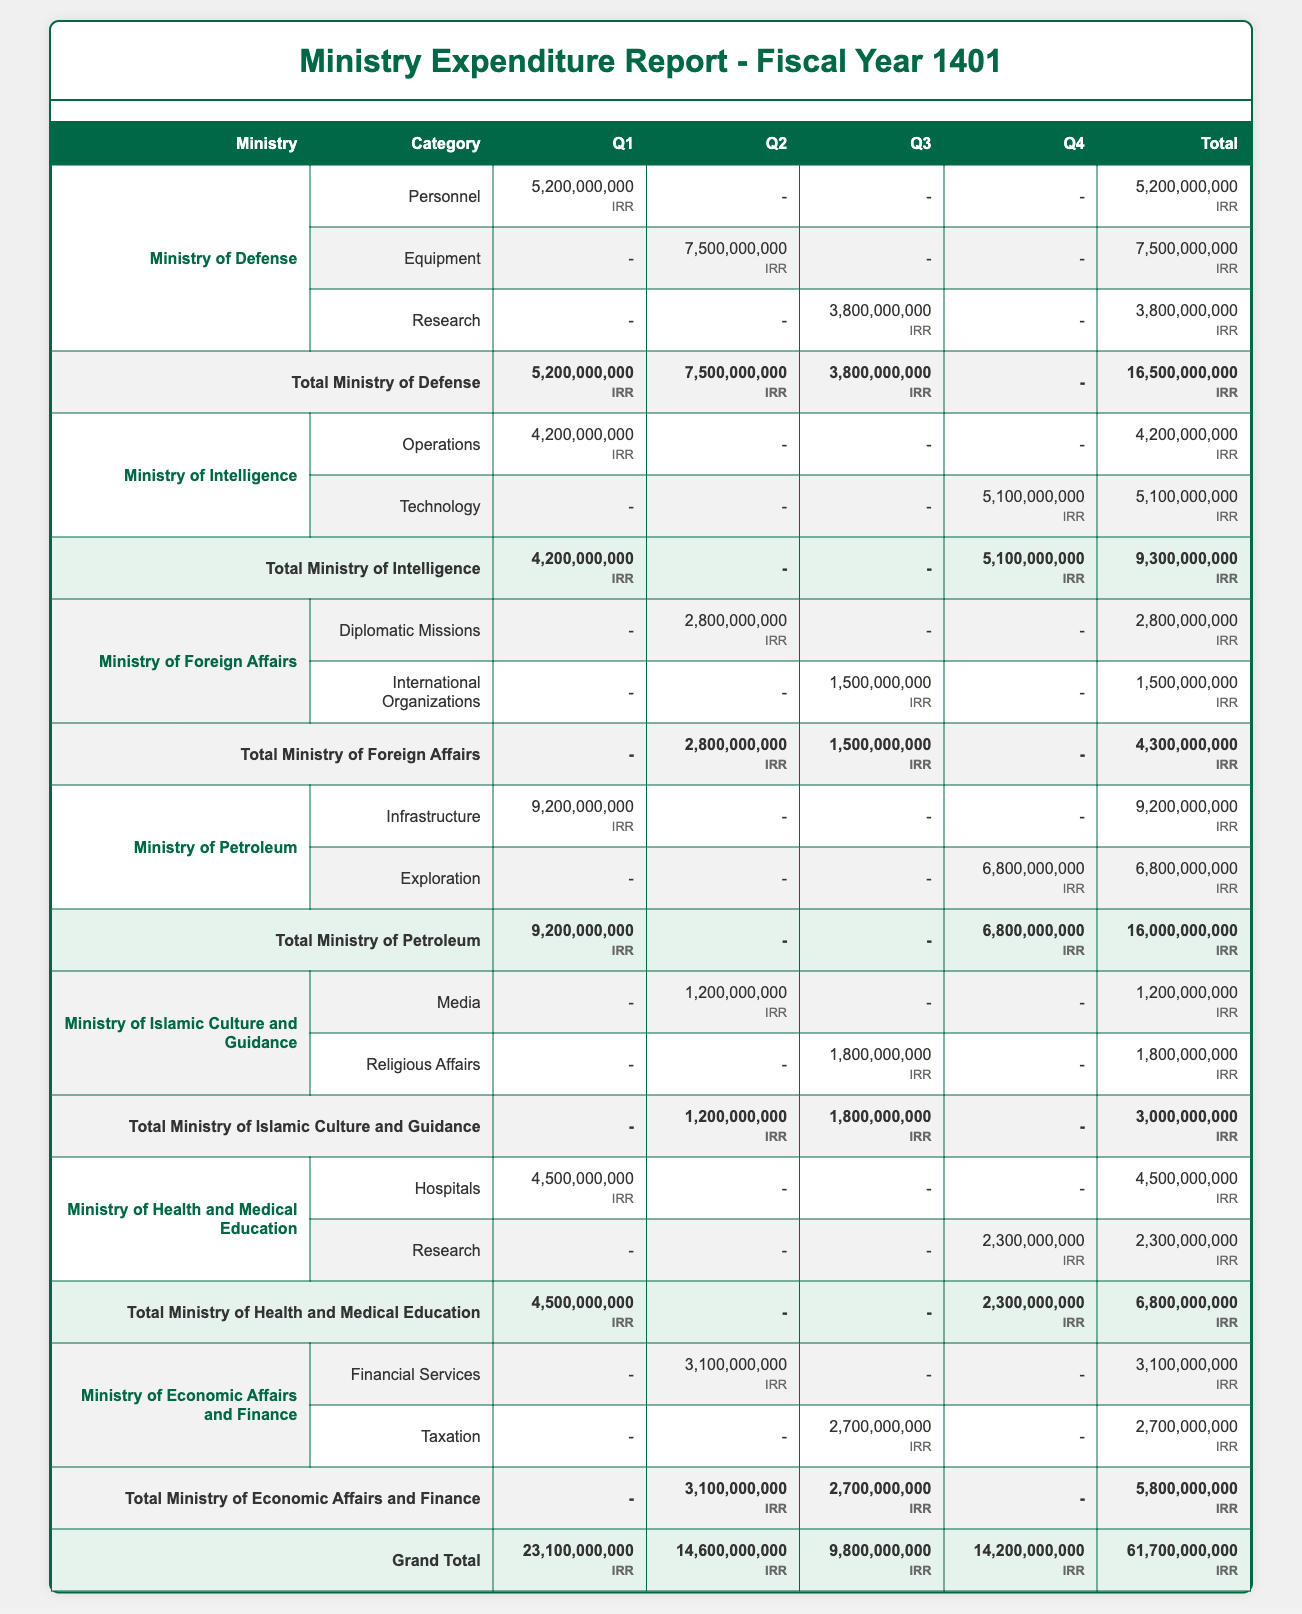What is the total expenditure for the Ministry of Defense? To find the total for the Ministry of Defense, we add up the total amounts under this ministry: 5,200,000,000 + 7,500,000,000 + 3,800,000,000 = 16,500,000,000 IRR.
Answer: 16,500,000,000 IRR Which ministry had the highest expenditure in Q1? By examining the Q1 expenditures for all ministries, we see the amounts: Ministry of Defense (5,200,000,000), Ministry of Intelligence (4,200,000,000), Ministry of Petroleum (9,200,000,000), Ministry of Health (4,500,000,000). The highest amount is from the Ministry of Petroleum at 9,200,000,000 IRR.
Answer: Ministry of Petroleum Did the Ministry of Foreign Affairs spend in Q1? When we look at the Q1 column for the Ministry of Foreign Affairs, we see that the expenditure is marked as "-" indicating no spending in that quarter.
Answer: No What is the difference in total expenditure between the Ministry of Petroleum and the Ministry of Islamic Culture and Guidance? First, we find the total for the Ministry of Petroleum: 16,000,000,000 IRR and for the Ministry of Islamic Culture and Guidance: 3,000,000,000 IRR. The difference is 16,000,000,000 - 3,000,000,000 = 13,000,000,000 IRR.
Answer: 13,000,000,000 IRR What is the average expenditure per category for the Ministry of Health and Medical Education? The Ministry of Health and Medical Education has two categories with expenditures: Hospitals (4,500,000,000 IRR) and Research (2,300,000,000 IRR). To find the average, we calculate (4,500,000,000 + 2,300,000,000) / 2 = 3,400,000,000 IRR.
Answer: 3,400,000,000 IRR Which quarter had the lowest total expenditures across all ministries? We can sum the expenditures for each quarter: Q1 (23,100,000,000 IRR), Q2 (14,600,000,000 IRR), Q3 (9,800,000,000 IRR), Q4 (14,200,000,000 IRR), where Q3 has the lowest total at 9,800,000,000 IRR.
Answer: Q3 Did the Ministry of Economic Affairs and Finance have any expenditures in Q1? Checking the Q1 expenditures for this ministry, it shows "-" indicating that there was no expenditure in that quarter.
Answer: No What was the total expenditure for the Ministry of Intelligence? To find the total, we add the expenditures: Operations (4,200,000,000) and Technology (5,100,000,000), which equals 4,200,000,000 + 5,100,000,000 = 9,300,000,000 IRR.
Answer: 9,300,000,000 IRR 